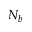<formula> <loc_0><loc_0><loc_500><loc_500>N _ { b }</formula> 